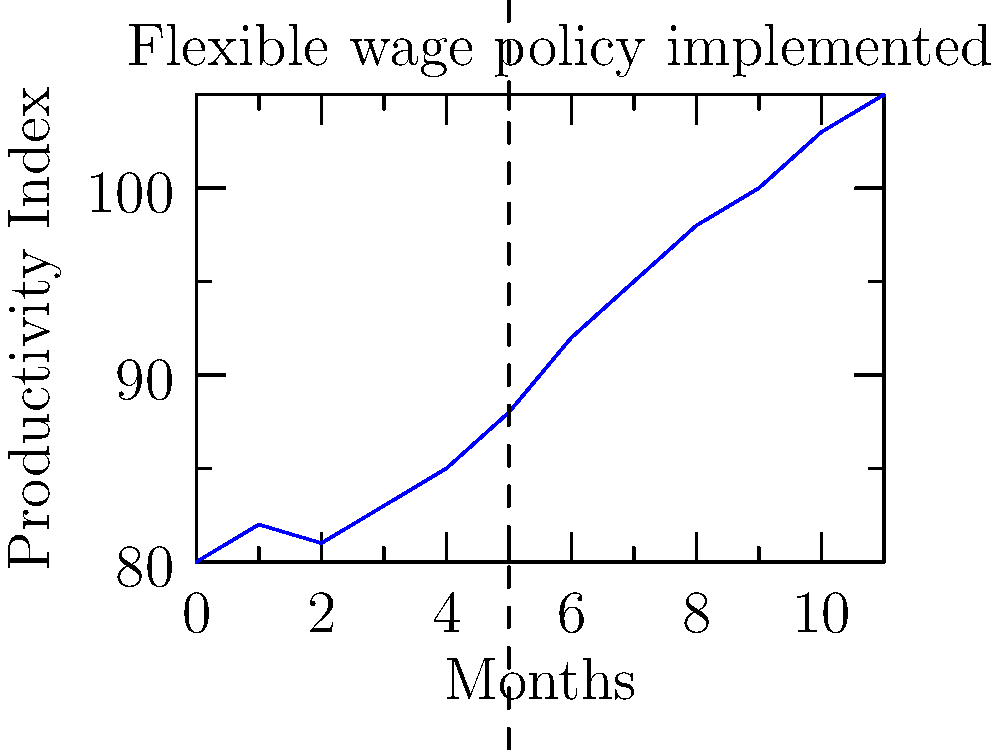Analyze the line graph showing productivity trends before and after implementing flexible wage policies. What is the approximate percentage increase in productivity six months after the policy implementation compared to the month of implementation? To solve this problem, we need to follow these steps:

1. Identify the month when the flexible wage policy was implemented:
   - The vertical dashed line indicates the implementation at month 5.

2. Determine the productivity index at the time of implementation:
   - At month 5, the productivity index is 88.

3. Find the productivity index 6 months after implementation:
   - 6 months after month 5 is month 11.
   - At month 11, the productivity index is 105.

4. Calculate the percentage increase:
   - Increase = New value - Original value = 105 - 88 = 17
   - Percentage increase = (Increase / Original value) × 100
   - Percentage increase = (17 / 88) × 100 ≈ 19.32%

5. Round to the nearest whole number:
   - 19.32% rounds to 19%

Therefore, the approximate percentage increase in productivity six months after the policy implementation is 19%.
Answer: 19% 